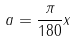<formula> <loc_0><loc_0><loc_500><loc_500>a = \frac { \pi } { 1 8 0 } x</formula> 